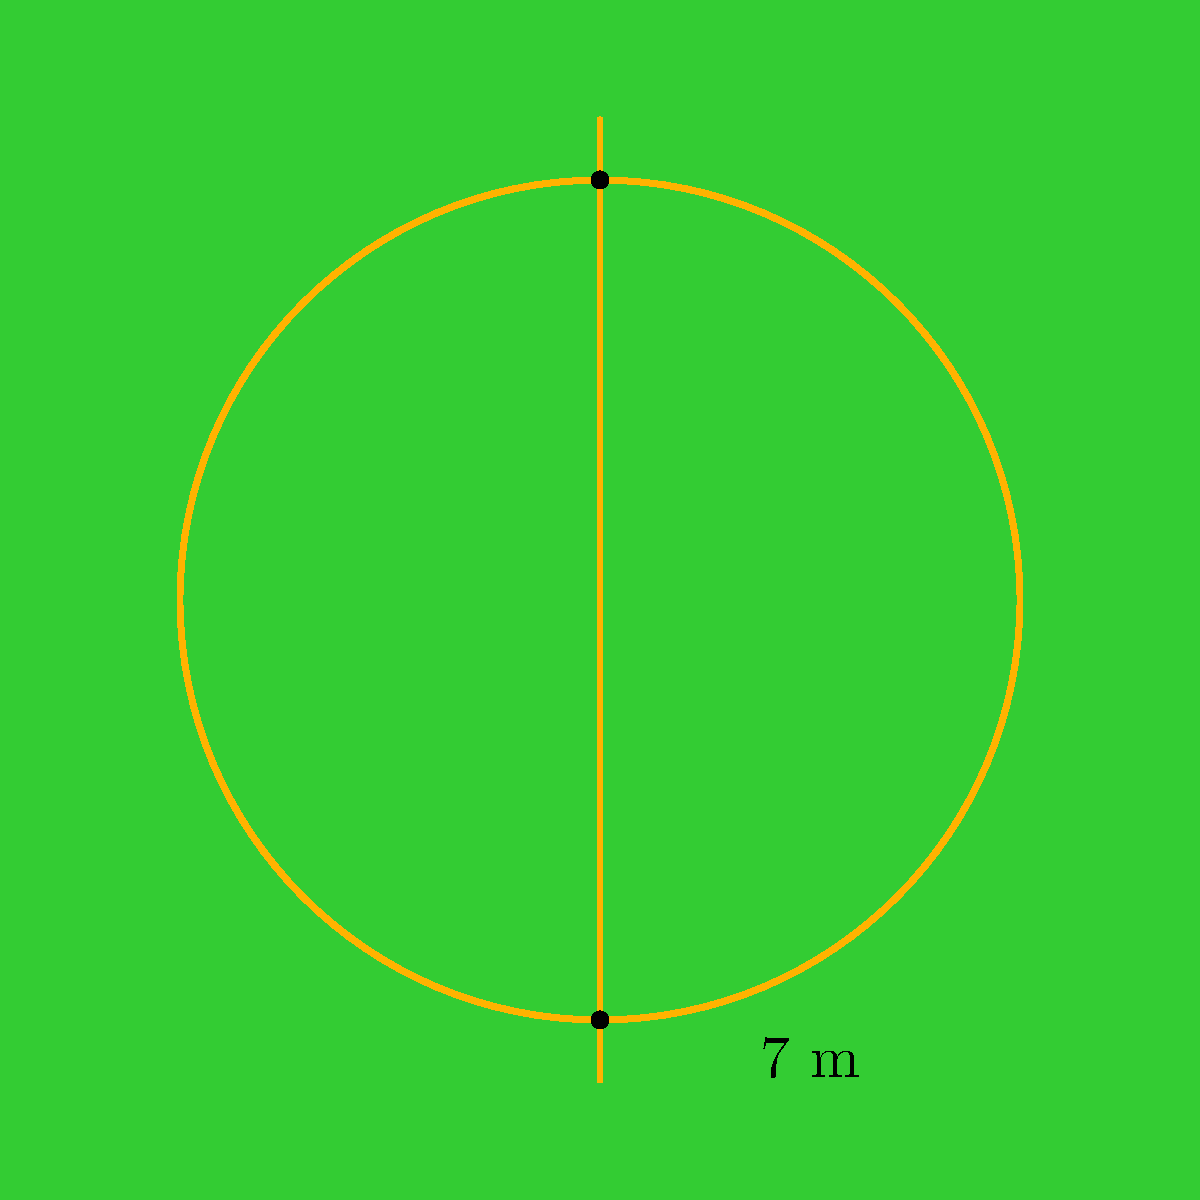Tom Naughton is practicing his kicks on a Gaelic football field. He notices the circular goalpost and wonders about its perimeter. If the diameter of the goalpost is 7 meters, what is the perimeter of the circular part of the goalpost? Let's solve this step-by-step:

1) The formula for the perimeter (circumference) of a circle is:
   $$C = \pi d$$
   where $C$ is the circumference, $\pi$ is pi, and $d$ is the diameter.

2) We're given that the diameter is 7 meters.

3) Let's substitute this into our formula:
   $$C = \pi \times 7$$

4) $\pi$ is approximately 3.14159, but for simplicity, we'll use 3.14.

5) Now we can calculate:
   $$C = 3.14 \times 7 = 21.98\text{ meters}$$

6) Rounding to two decimal places:
   $$C \approx 21.98\text{ meters}$$

This means that if Tom were to walk around the circular part of the goalpost, he would travel approximately 21.98 meters.
Answer: 21.98 meters 